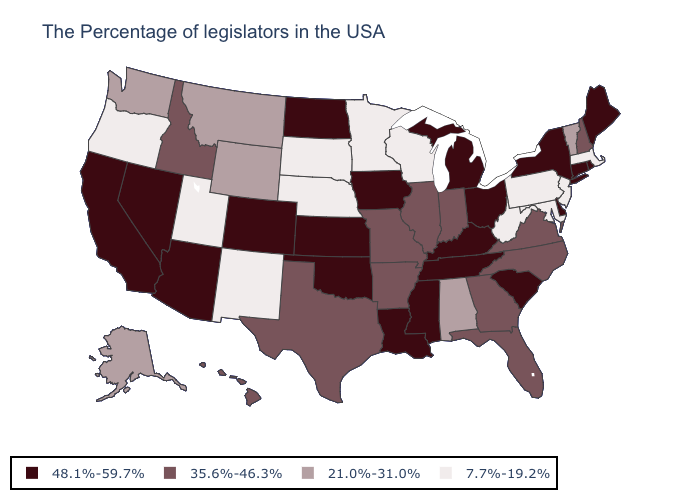What is the value of Pennsylvania?
Short answer required. 7.7%-19.2%. Which states have the highest value in the USA?
Give a very brief answer. Maine, Rhode Island, Connecticut, New York, Delaware, South Carolina, Ohio, Michigan, Kentucky, Tennessee, Mississippi, Louisiana, Iowa, Kansas, Oklahoma, North Dakota, Colorado, Arizona, Nevada, California. Does the map have missing data?
Write a very short answer. No. Name the states that have a value in the range 7.7%-19.2%?
Short answer required. Massachusetts, New Jersey, Maryland, Pennsylvania, West Virginia, Wisconsin, Minnesota, Nebraska, South Dakota, New Mexico, Utah, Oregon. Does the first symbol in the legend represent the smallest category?
Answer briefly. No. Does Massachusetts have a higher value than Pennsylvania?
Keep it brief. No. Name the states that have a value in the range 21.0%-31.0%?
Quick response, please. Vermont, Alabama, Wyoming, Montana, Washington, Alaska. What is the highest value in the USA?
Be succinct. 48.1%-59.7%. Does Wisconsin have a lower value than Maryland?
Quick response, please. No. What is the value of Missouri?
Short answer required. 35.6%-46.3%. What is the highest value in the USA?
Write a very short answer. 48.1%-59.7%. Which states have the highest value in the USA?
Write a very short answer. Maine, Rhode Island, Connecticut, New York, Delaware, South Carolina, Ohio, Michigan, Kentucky, Tennessee, Mississippi, Louisiana, Iowa, Kansas, Oklahoma, North Dakota, Colorado, Arizona, Nevada, California. What is the lowest value in the Northeast?
Write a very short answer. 7.7%-19.2%. Does Missouri have the highest value in the MidWest?
Short answer required. No. Does New Jersey have the same value as Pennsylvania?
Write a very short answer. Yes. 